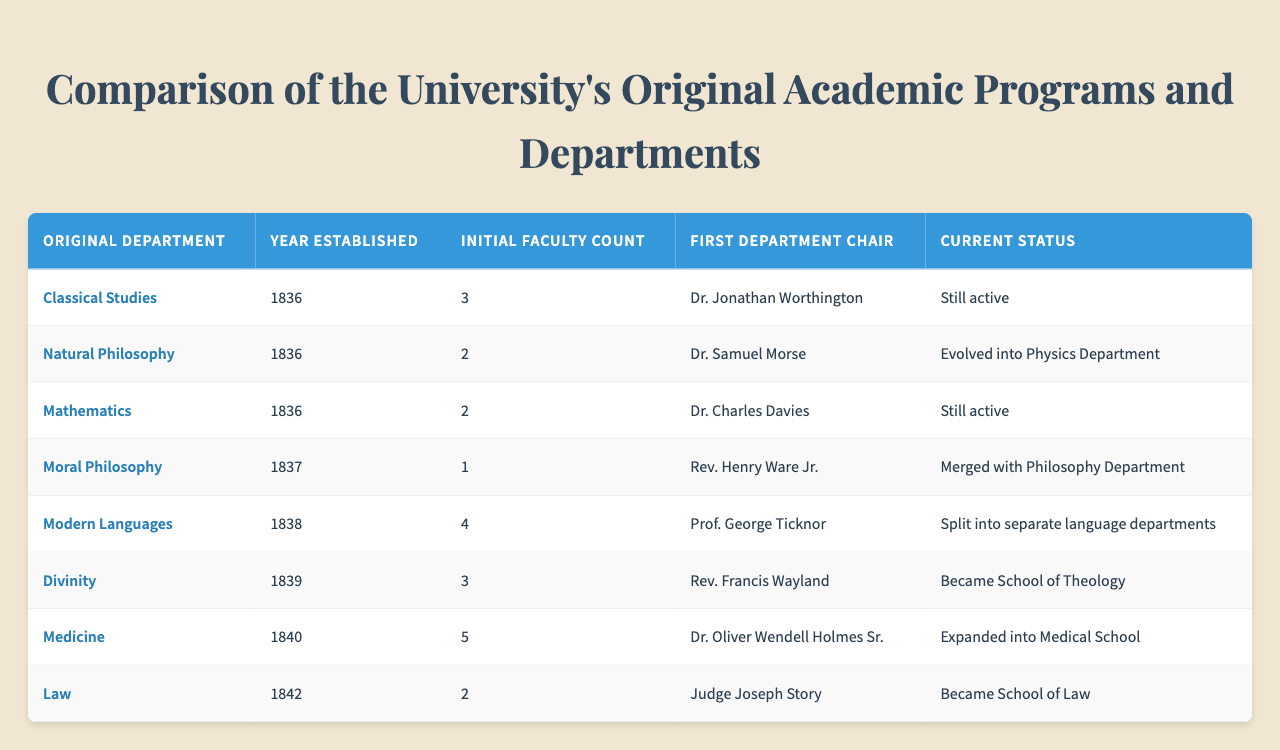What year was the Mathematics department established? Referring to the table, the Mathematics department's established year is listed directly under the "Year Established" column. It shows that it was established in 1836.
Answer: 1836 Who was the first chair of the Divinity department? Looking at the "First Department Chair" column for the Divinity department row, it indicates that Rev. Francis Wayland was the first chair.
Answer: Rev. Francis Wayland Which original department evolved into the Physics Department? The table states in the "Current Status" column that the Natural Philosophy department evolved into the Physics Department.
Answer: Natural Philosophy How many initial faculty members were there in the Modern Languages department? By checking the "Initial Faculty Count" for the Modern Languages department, it indicates that there were 4 initial faculty members.
Answer: 4 Is the Classical Studies department still active? The "Current Status" column for the Classical Studies department shows "Still active," confirming that the department is currently operational.
Answer: Yes What was the fate of the Moral Philosophy department? The "Current Status" for Moral Philosophy indicates that it merged with the Philosophy Department, showing its fate as a merger.
Answer: Merged with Philosophy Department How many departments were established in 1836? By inspecting the table, three departments (Classical Studies, Natural Philosophy, and Mathematics) were established in 1836. This involves counting the rows corresponding to that year.
Answer: 3 Which department had the highest initial faculty count, and how many were there? Checking the "Initial Faculty Count" column, the Medicine department had the highest initial faculty count of 5 as shown in its respective row.
Answer: Medicine, 5 Which department was founded first, and who was its first chair? The first department established was Classical Studies in 1836, with Dr. Jonathan Worthington as its first chair. This is determined by inspecting the earliest year in the "Year Established" column.
Answer: Classical Studies, Dr. Jonathan Worthington If we sum the initial faculty counts of all departments, what total do we get? Adding the initial faculty counts: 3 (Classical Studies) + 2 (Natural Philosophy) + 2 (Mathematics) + 1 (Moral Philosophy) + 4 (Modern Languages) + 3 (Divinity) + 5 (Medicine) + 2 (Law) yields 22 total initial faculty members. The calculation is 3 + 2 + 2 + 1 + 4 + 3 + 5 + 2 = 22.
Answer: 22 